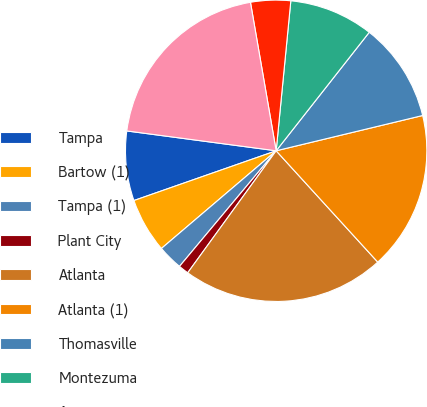<chart> <loc_0><loc_0><loc_500><loc_500><pie_chart><fcel>Tampa<fcel>Bartow (1)<fcel>Tampa (1)<fcel>Plant City<fcel>Atlanta<fcel>Atlanta (1)<fcel>Thomasville<fcel>Montezuma<fcel>Augusta<fcel>Burley (1)<nl><fcel>7.46%<fcel>5.87%<fcel>2.69%<fcel>1.1%<fcel>21.76%<fcel>16.99%<fcel>10.64%<fcel>9.05%<fcel>4.28%<fcel>20.17%<nl></chart> 